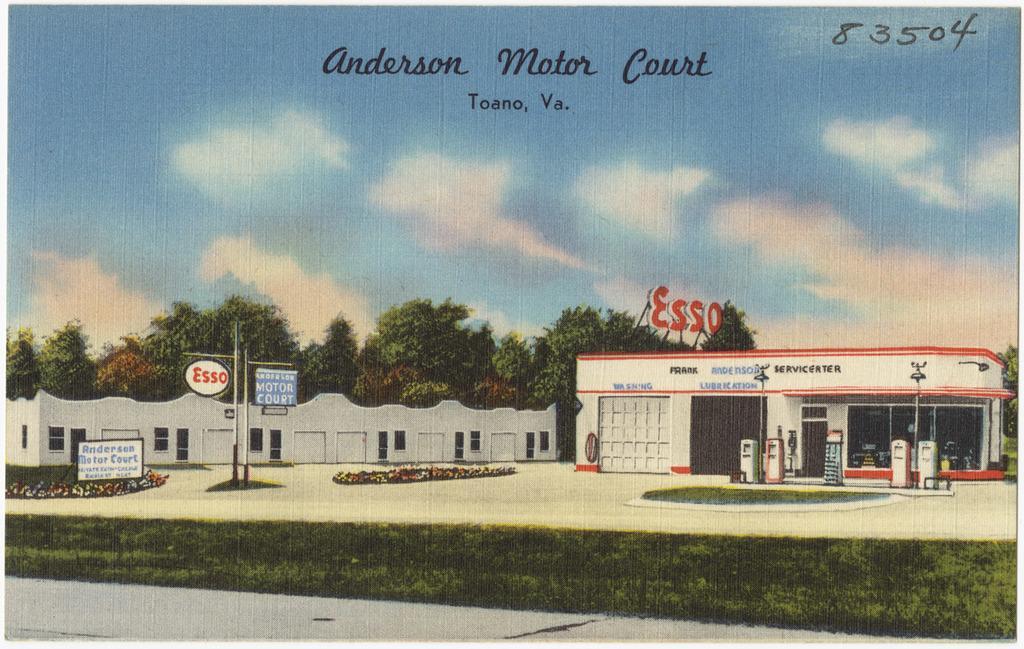Describe this image in one or two sentences. There is grassland in the foreground area of the image, there are flower plants, poles, it seems like fuel dispensers, building structures, trees and the sky in the background. There is text at the top side. 